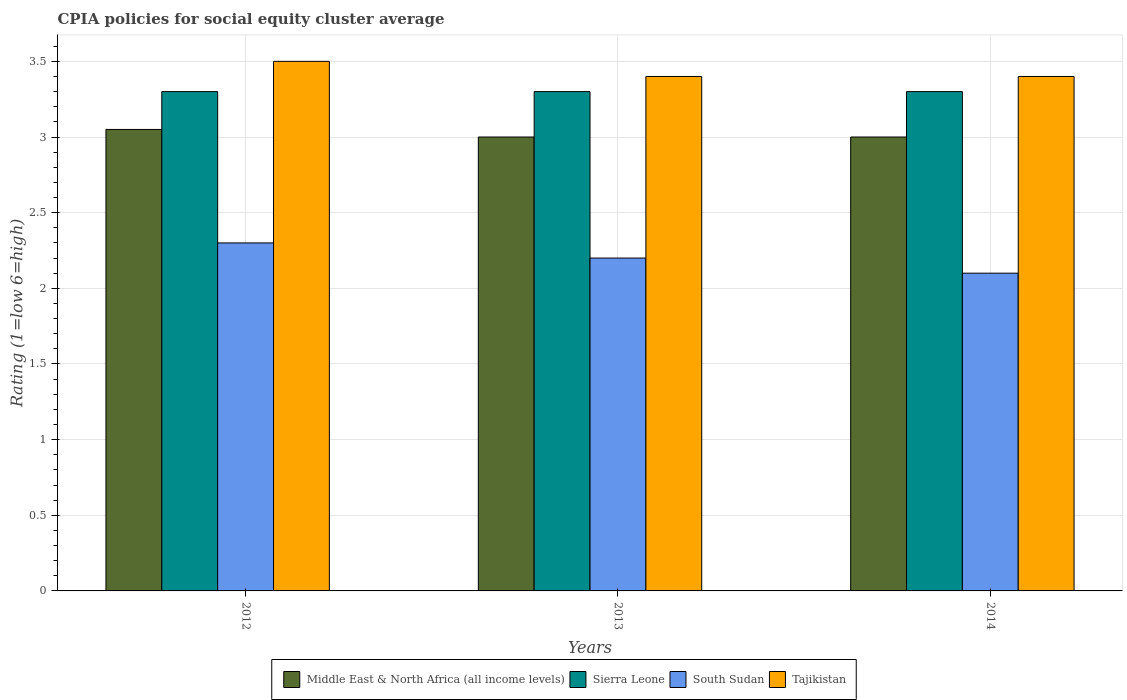Are the number of bars per tick equal to the number of legend labels?
Your answer should be very brief. Yes. Are the number of bars on each tick of the X-axis equal?
Make the answer very short. Yes. What is the label of the 3rd group of bars from the left?
Your response must be concise. 2014. What is the CPIA rating in Tajikistan in 2014?
Keep it short and to the point. 3.4. Across all years, what is the maximum CPIA rating in Sierra Leone?
Offer a very short reply. 3.3. Across all years, what is the minimum CPIA rating in Sierra Leone?
Make the answer very short. 3.3. In which year was the CPIA rating in Middle East & North Africa (all income levels) maximum?
Your answer should be compact. 2012. In which year was the CPIA rating in Middle East & North Africa (all income levels) minimum?
Keep it short and to the point. 2013. What is the difference between the CPIA rating in Tajikistan in 2012 and that in 2014?
Keep it short and to the point. 0.1. What is the difference between the CPIA rating in Sierra Leone in 2012 and the CPIA rating in South Sudan in 2013?
Ensure brevity in your answer.  1.1. What is the average CPIA rating in Sierra Leone per year?
Provide a succinct answer. 3.3. In the year 2013, what is the difference between the CPIA rating in Tajikistan and CPIA rating in Middle East & North Africa (all income levels)?
Give a very brief answer. 0.4. What is the ratio of the CPIA rating in Tajikistan in 2012 to that in 2014?
Keep it short and to the point. 1.03. What is the difference between the highest and the second highest CPIA rating in South Sudan?
Offer a very short reply. 0.1. In how many years, is the CPIA rating in Middle East & North Africa (all income levels) greater than the average CPIA rating in Middle East & North Africa (all income levels) taken over all years?
Your response must be concise. 1. Is the sum of the CPIA rating in South Sudan in 2012 and 2013 greater than the maximum CPIA rating in Middle East & North Africa (all income levels) across all years?
Ensure brevity in your answer.  Yes. Is it the case that in every year, the sum of the CPIA rating in South Sudan and CPIA rating in Sierra Leone is greater than the sum of CPIA rating in Tajikistan and CPIA rating in Middle East & North Africa (all income levels)?
Provide a succinct answer. No. What does the 4th bar from the left in 2012 represents?
Make the answer very short. Tajikistan. What does the 4th bar from the right in 2013 represents?
Offer a very short reply. Middle East & North Africa (all income levels). How many years are there in the graph?
Keep it short and to the point. 3. What is the difference between two consecutive major ticks on the Y-axis?
Your answer should be very brief. 0.5. Does the graph contain grids?
Give a very brief answer. Yes. Where does the legend appear in the graph?
Ensure brevity in your answer.  Bottom center. What is the title of the graph?
Keep it short and to the point. CPIA policies for social equity cluster average. Does "Iceland" appear as one of the legend labels in the graph?
Your answer should be compact. No. What is the Rating (1=low 6=high) of Middle East & North Africa (all income levels) in 2012?
Offer a very short reply. 3.05. What is the Rating (1=low 6=high) in Tajikistan in 2012?
Make the answer very short. 3.5. What is the Rating (1=low 6=high) in South Sudan in 2013?
Your answer should be compact. 2.2. What is the Rating (1=low 6=high) in Tajikistan in 2013?
Provide a succinct answer. 3.4. What is the Rating (1=low 6=high) of Middle East & North Africa (all income levels) in 2014?
Offer a terse response. 3. Across all years, what is the maximum Rating (1=low 6=high) of Middle East & North Africa (all income levels)?
Keep it short and to the point. 3.05. Across all years, what is the maximum Rating (1=low 6=high) of Sierra Leone?
Offer a very short reply. 3.3. Across all years, what is the maximum Rating (1=low 6=high) in Tajikistan?
Make the answer very short. 3.5. Across all years, what is the minimum Rating (1=low 6=high) of South Sudan?
Offer a very short reply. 2.1. What is the total Rating (1=low 6=high) of Middle East & North Africa (all income levels) in the graph?
Provide a succinct answer. 9.05. What is the total Rating (1=low 6=high) in Sierra Leone in the graph?
Make the answer very short. 9.9. What is the total Rating (1=low 6=high) in South Sudan in the graph?
Provide a succinct answer. 6.6. What is the difference between the Rating (1=low 6=high) in South Sudan in 2012 and that in 2013?
Your answer should be compact. 0.1. What is the difference between the Rating (1=low 6=high) of Tajikistan in 2012 and that in 2013?
Give a very brief answer. 0.1. What is the difference between the Rating (1=low 6=high) of Tajikistan in 2013 and that in 2014?
Your response must be concise. 0. What is the difference between the Rating (1=low 6=high) in Middle East & North Africa (all income levels) in 2012 and the Rating (1=low 6=high) in Sierra Leone in 2013?
Make the answer very short. -0.25. What is the difference between the Rating (1=low 6=high) of Middle East & North Africa (all income levels) in 2012 and the Rating (1=low 6=high) of South Sudan in 2013?
Your answer should be very brief. 0.85. What is the difference between the Rating (1=low 6=high) of Middle East & North Africa (all income levels) in 2012 and the Rating (1=low 6=high) of Tajikistan in 2013?
Your answer should be compact. -0.35. What is the difference between the Rating (1=low 6=high) of Sierra Leone in 2012 and the Rating (1=low 6=high) of South Sudan in 2013?
Keep it short and to the point. 1.1. What is the difference between the Rating (1=low 6=high) of South Sudan in 2012 and the Rating (1=low 6=high) of Tajikistan in 2013?
Provide a succinct answer. -1.1. What is the difference between the Rating (1=low 6=high) in Middle East & North Africa (all income levels) in 2012 and the Rating (1=low 6=high) in South Sudan in 2014?
Keep it short and to the point. 0.95. What is the difference between the Rating (1=low 6=high) of Middle East & North Africa (all income levels) in 2012 and the Rating (1=low 6=high) of Tajikistan in 2014?
Keep it short and to the point. -0.35. What is the difference between the Rating (1=low 6=high) in Sierra Leone in 2012 and the Rating (1=low 6=high) in Tajikistan in 2014?
Your response must be concise. -0.1. What is the difference between the Rating (1=low 6=high) in South Sudan in 2012 and the Rating (1=low 6=high) in Tajikistan in 2014?
Your answer should be very brief. -1.1. What is the difference between the Rating (1=low 6=high) of Middle East & North Africa (all income levels) in 2013 and the Rating (1=low 6=high) of Sierra Leone in 2014?
Offer a terse response. -0.3. What is the difference between the Rating (1=low 6=high) of Middle East & North Africa (all income levels) in 2013 and the Rating (1=low 6=high) of South Sudan in 2014?
Offer a terse response. 0.9. What is the difference between the Rating (1=low 6=high) in South Sudan in 2013 and the Rating (1=low 6=high) in Tajikistan in 2014?
Your answer should be very brief. -1.2. What is the average Rating (1=low 6=high) of Middle East & North Africa (all income levels) per year?
Make the answer very short. 3.02. What is the average Rating (1=low 6=high) in Sierra Leone per year?
Give a very brief answer. 3.3. What is the average Rating (1=low 6=high) in Tajikistan per year?
Provide a short and direct response. 3.43. In the year 2012, what is the difference between the Rating (1=low 6=high) in Middle East & North Africa (all income levels) and Rating (1=low 6=high) in Sierra Leone?
Your response must be concise. -0.25. In the year 2012, what is the difference between the Rating (1=low 6=high) in Middle East & North Africa (all income levels) and Rating (1=low 6=high) in South Sudan?
Make the answer very short. 0.75. In the year 2012, what is the difference between the Rating (1=low 6=high) in Middle East & North Africa (all income levels) and Rating (1=low 6=high) in Tajikistan?
Give a very brief answer. -0.45. In the year 2012, what is the difference between the Rating (1=low 6=high) in Sierra Leone and Rating (1=low 6=high) in South Sudan?
Provide a short and direct response. 1. In the year 2012, what is the difference between the Rating (1=low 6=high) of South Sudan and Rating (1=low 6=high) of Tajikistan?
Provide a short and direct response. -1.2. In the year 2013, what is the difference between the Rating (1=low 6=high) of Sierra Leone and Rating (1=low 6=high) of South Sudan?
Provide a short and direct response. 1.1. In the year 2013, what is the difference between the Rating (1=low 6=high) in South Sudan and Rating (1=low 6=high) in Tajikistan?
Your response must be concise. -1.2. In the year 2014, what is the difference between the Rating (1=low 6=high) of Middle East & North Africa (all income levels) and Rating (1=low 6=high) of Tajikistan?
Offer a very short reply. -0.4. What is the ratio of the Rating (1=low 6=high) of Middle East & North Africa (all income levels) in 2012 to that in 2013?
Your answer should be compact. 1.02. What is the ratio of the Rating (1=low 6=high) in Sierra Leone in 2012 to that in 2013?
Provide a short and direct response. 1. What is the ratio of the Rating (1=low 6=high) in South Sudan in 2012 to that in 2013?
Offer a terse response. 1.05. What is the ratio of the Rating (1=low 6=high) of Tajikistan in 2012 to that in 2013?
Your answer should be very brief. 1.03. What is the ratio of the Rating (1=low 6=high) in Middle East & North Africa (all income levels) in 2012 to that in 2014?
Provide a short and direct response. 1.02. What is the ratio of the Rating (1=low 6=high) of Sierra Leone in 2012 to that in 2014?
Your response must be concise. 1. What is the ratio of the Rating (1=low 6=high) in South Sudan in 2012 to that in 2014?
Provide a succinct answer. 1.1. What is the ratio of the Rating (1=low 6=high) of Tajikistan in 2012 to that in 2014?
Keep it short and to the point. 1.03. What is the ratio of the Rating (1=low 6=high) in Middle East & North Africa (all income levels) in 2013 to that in 2014?
Keep it short and to the point. 1. What is the ratio of the Rating (1=low 6=high) of Sierra Leone in 2013 to that in 2014?
Keep it short and to the point. 1. What is the ratio of the Rating (1=low 6=high) in South Sudan in 2013 to that in 2014?
Your answer should be very brief. 1.05. What is the ratio of the Rating (1=low 6=high) of Tajikistan in 2013 to that in 2014?
Your response must be concise. 1. What is the difference between the highest and the second highest Rating (1=low 6=high) of Middle East & North Africa (all income levels)?
Your answer should be very brief. 0.05. What is the difference between the highest and the second highest Rating (1=low 6=high) in South Sudan?
Give a very brief answer. 0.1. What is the difference between the highest and the lowest Rating (1=low 6=high) of Tajikistan?
Your answer should be compact. 0.1. 